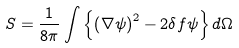<formula> <loc_0><loc_0><loc_500><loc_500>S = \frac { 1 } { 8 \pi } \int \left \{ \left ( \nabla \psi \right ) ^ { 2 } - 2 \delta f \psi \right \} d \Omega</formula> 